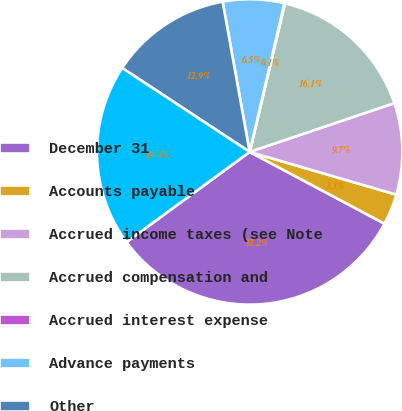Convert chart. <chart><loc_0><loc_0><loc_500><loc_500><pie_chart><fcel>December 31<fcel>Accounts payable<fcel>Accrued income taxes (see Note<fcel>Accrued compensation and<fcel>Accrued interest expense<fcel>Advance payments<fcel>Other<fcel>Total<nl><fcel>32.16%<fcel>3.27%<fcel>9.69%<fcel>16.11%<fcel>0.06%<fcel>6.48%<fcel>12.9%<fcel>19.32%<nl></chart> 